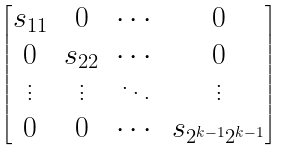Convert formula to latex. <formula><loc_0><loc_0><loc_500><loc_500>\begin{bmatrix} s _ { 1 1 } & 0 & \cdots & 0 \\ 0 & s _ { 2 2 } & \cdots & 0 \\ \vdots & \vdots & \ddots & \vdots \\ 0 & 0 & \cdots & s _ { 2 ^ { k - 1 } 2 ^ { k - 1 } } \\ \end{bmatrix}</formula> 